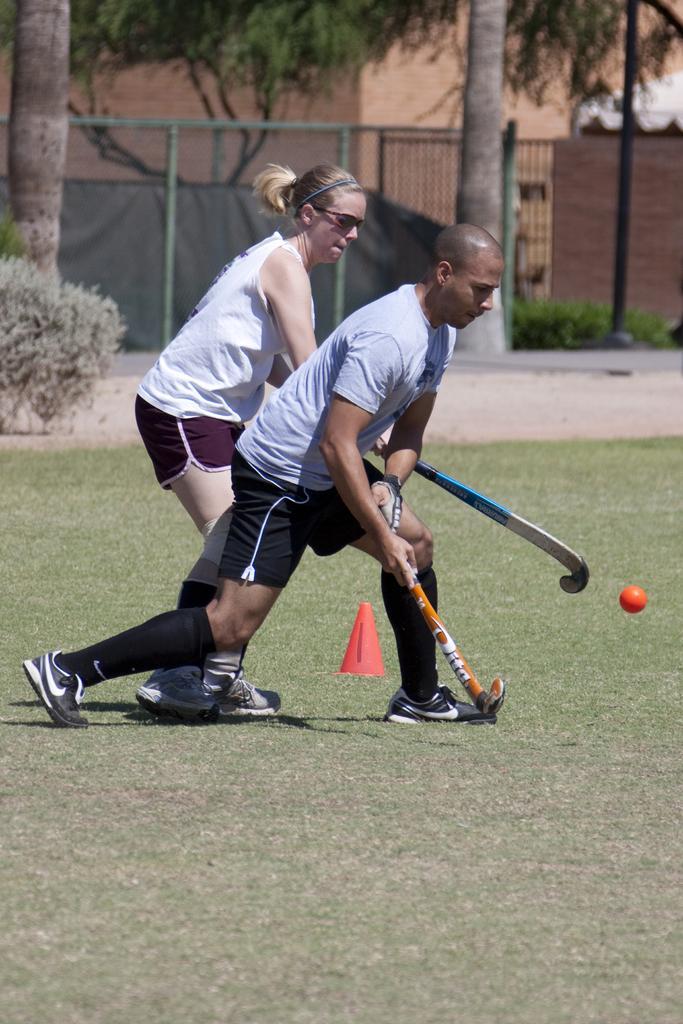Describe this image in one or two sentences. As we can see in the image there are two people, a ball ,traffic cone, grass, plants, fence, trees and buildings. 